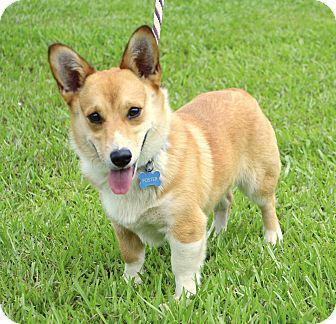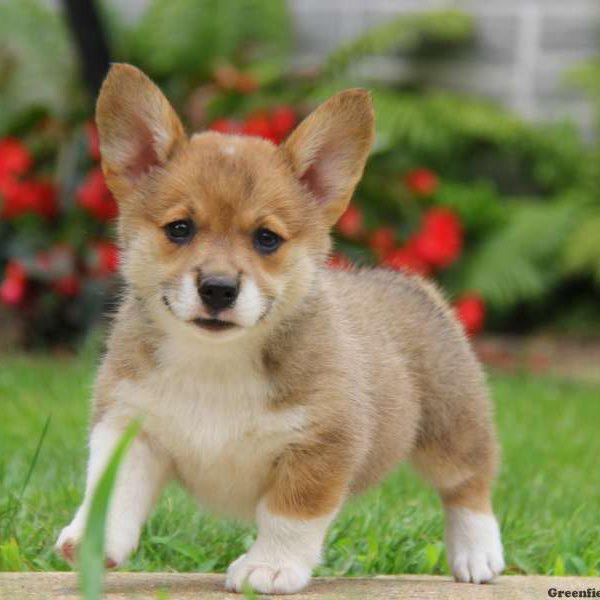The first image is the image on the left, the second image is the image on the right. Analyze the images presented: Is the assertion "The dog in the right image is not posed with grass in the background." valid? Answer yes or no. No. 